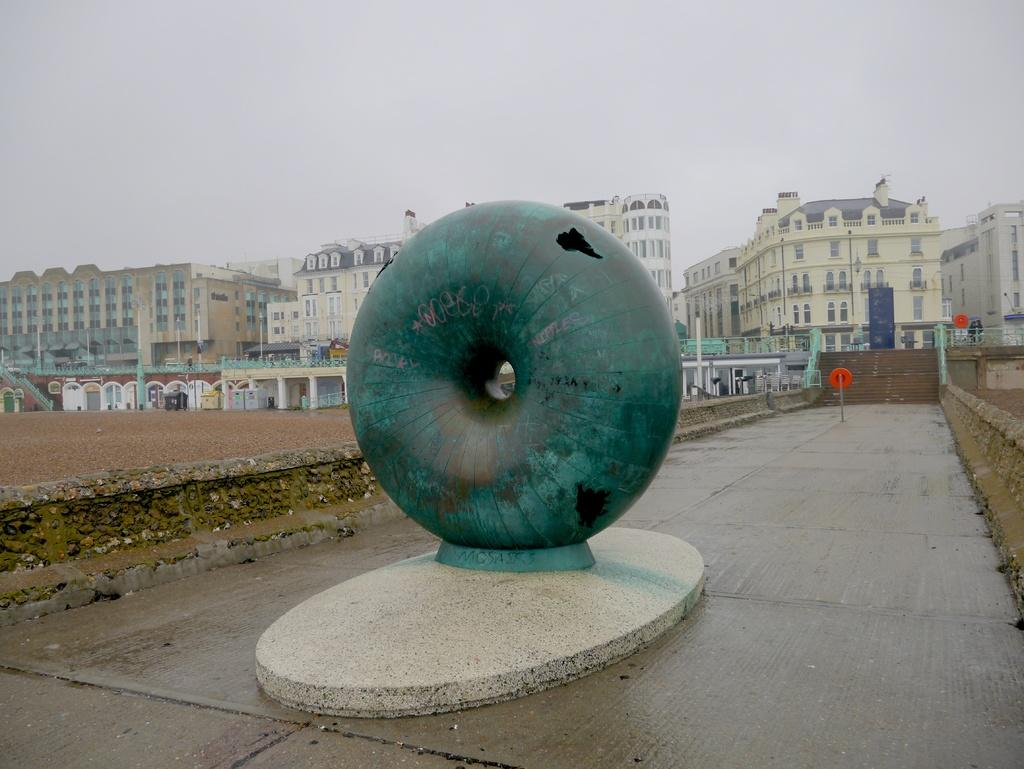What type of concrete object is in the image? The image features a concrete object, but the specific type is not mentioned in the facts. What else can be seen in the image besides the concrete object? There are buildings in the image. What features do the buildings have? The buildings have windows, stairs, and railing. What is visible in the background of the image? The sky is visible in the image. Where is the scarecrow located in the image? There is no scarecrow present in the image. Can you see an airplane flying in the sky in the image? The facts do not mention an airplane, so it cannot be determined if one is present in the image. Is there a swing visible in the image? There is no mention of a swing in the provided facts, so it cannot be determined if one is present in the image. 